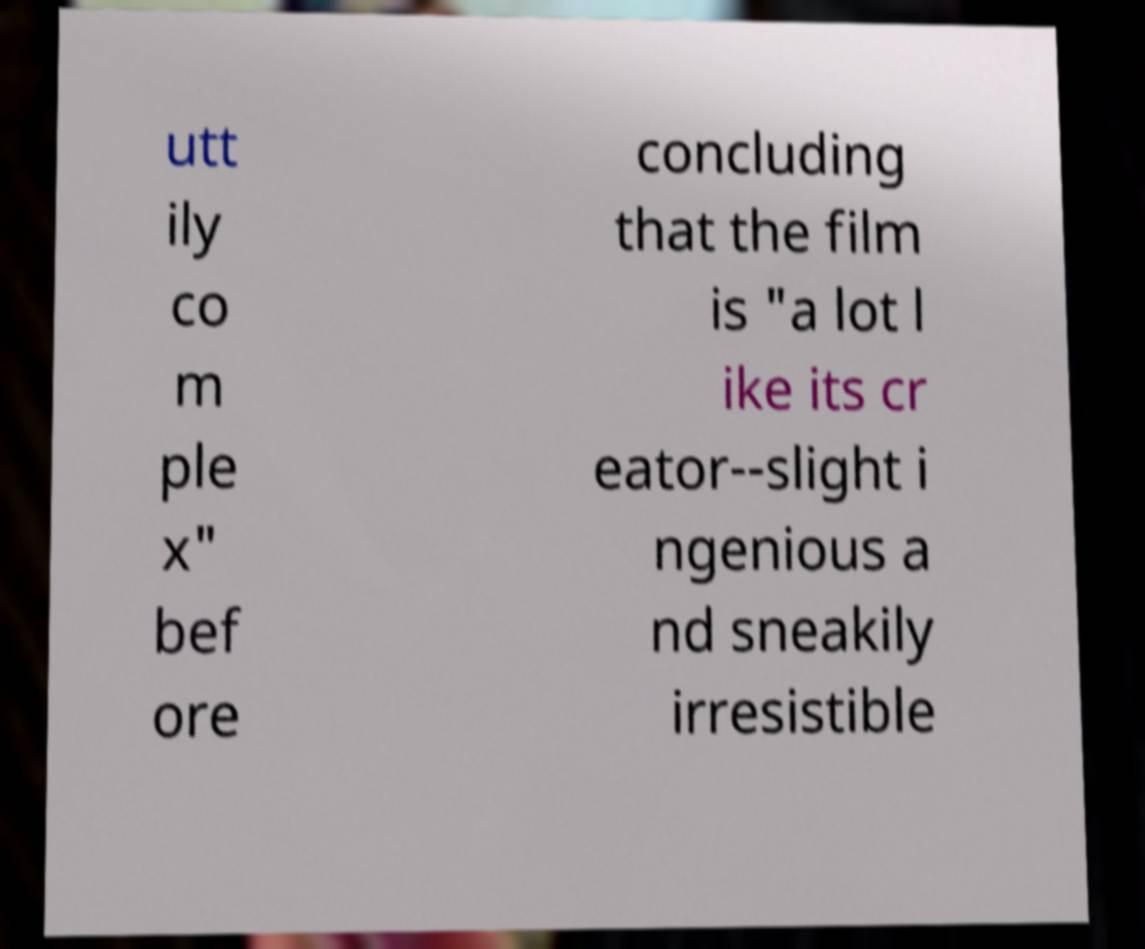Could you extract and type out the text from this image? utt ily co m ple x" bef ore concluding that the film is "a lot l ike its cr eator--slight i ngenious a nd sneakily irresistible 